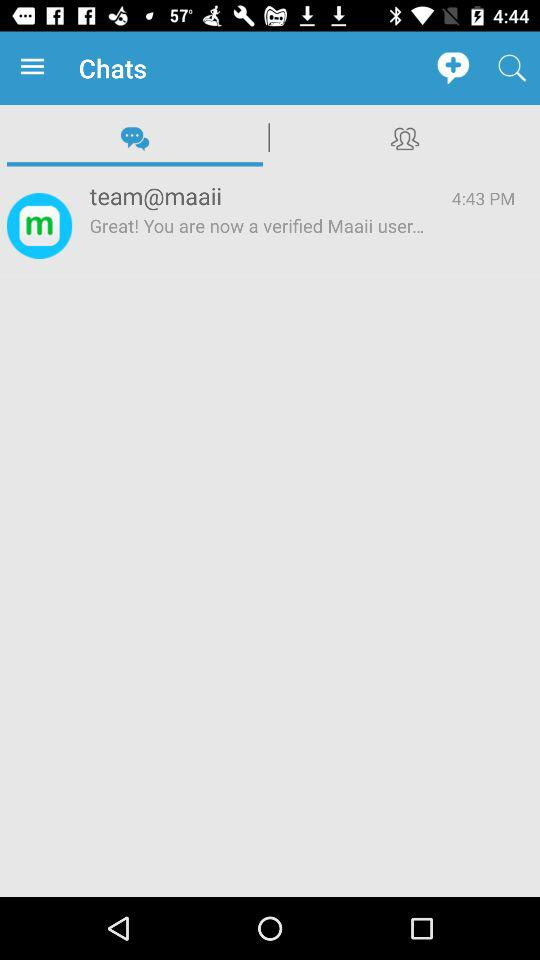How long ago was this message sent?
Answer the question using a single word or phrase. 4:43 PM 